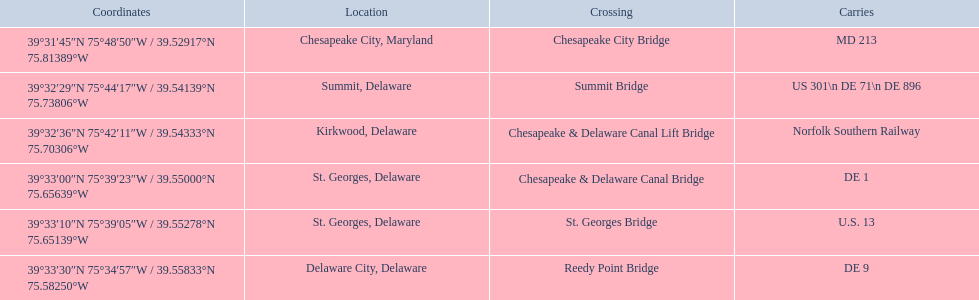What is being carried in the canal? MD 213, US 301\n DE 71\n DE 896, Norfolk Southern Railway, DE 1, U.S. 13, DE 9. Of those which has the largest number of different routes? US 301\n DE 71\n DE 896. To which crossing does that relate? Summit Bridge. 